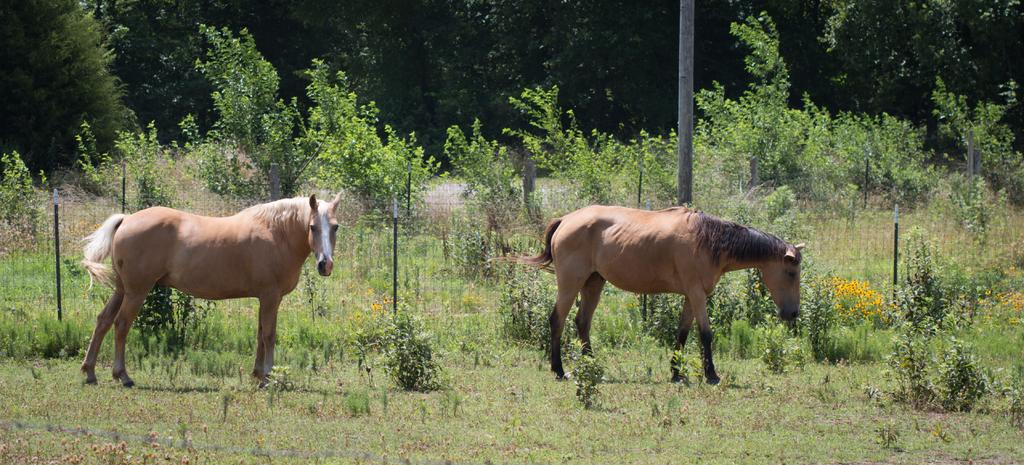What animals are present in the image? There are two horses standing on the ground in the image. What type of vegetation can be seen in the image? There are plants with flowers and plants in the background of the image. What is the ground made of in the image? Grass is present in the image. What structures are visible in the image? There is a fence and a pole in the image. What can be seen in the background of the image? There are trees in the background of the image. What type of pear can be seen hanging from the pole in the image? There is no pear present in the image; the pole is a separate structure from the plants and trees. 